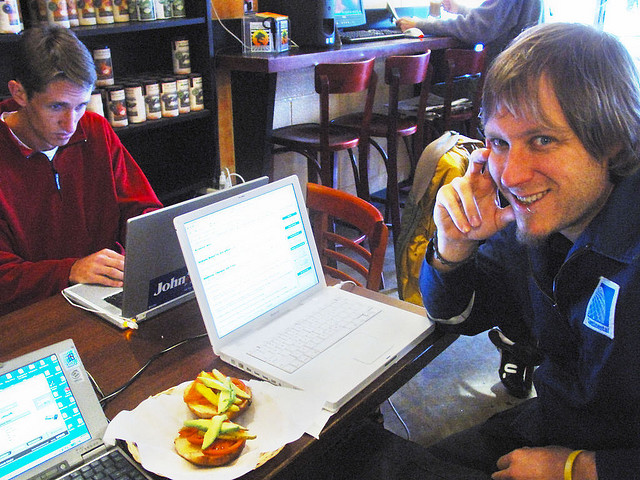What are the green items on top of the tomatoes on the man's sandwich? The green items on top of the tomatoes on the man's sandwich appear to be slices of avocado. These are characterized by their distinctive shape and creamy texture, which is typically richer than the crispness of lettuce or pickles. Avocado on sandwiches is popular for its flavor and health benefits as it is high in beneficial fats. 